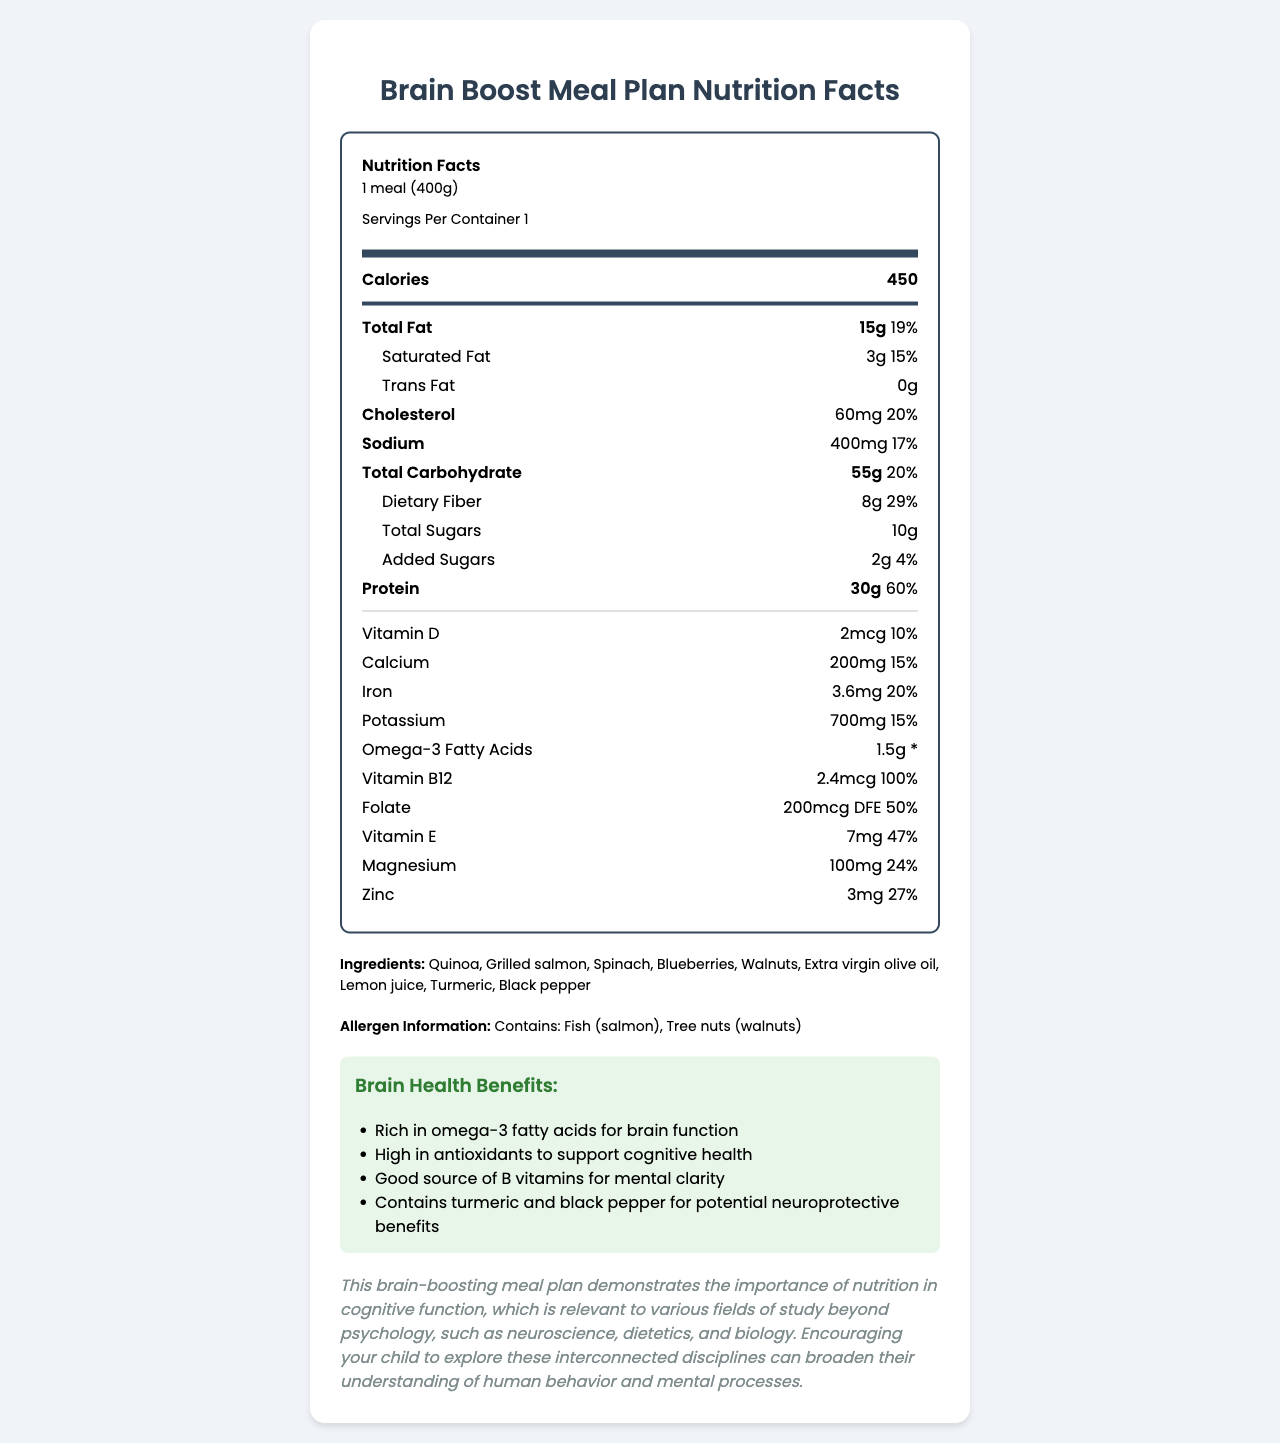what is the serving size of this meal? The document specifies that the serving size is "1 meal (400g)" in the nutrition header section.
Answer: 1 meal (400g) how many calories are in one serving? The document lists "Calories" as 450 in the bold section of the nutrition label.
Answer: 450 Which nutrient has the highest % Daily Value per serving? A. Protein B. Folate C. Dietary Fiber The document shows Protein as 60%, Folate as 50%, and Dietary Fiber as 29%. Protein has the highest % Daily Value at 60%.
Answer: A Is there any trans fat in this meal? The document states "Trans Fat" is 0g, meaning there is no trans fat in this meal.
Answer: No what are the main sources of omega-3 fatty acids in this meal? The ingredients list includes "Grilled salmon" and "Walnuts," both known for being rich in omega-3 fatty acids.
Answer: Grilled salmon, Walnuts how much protein is in one serving? The document lists Protein content as 30g.
Answer: 30g what is the amount of added sugars in this meal? The document specifies the amount of "Added Sugars" as 2g.
Answer: 2g Which vitamin has the highest % Daily Value and what is its value? The document indicates that Vitamin B12 has a % Daily Value of 100%, the highest among all the listed vitamins.
Answer: Vitamin B12, 100% Does this meal contain any allergens? The document states under allergen information that it contains Fish (salmon) and Tree nuts (walnuts).
Answer: Yes Summarize the main features of this document. The document is a well-rounded summary giving insights on nutritional aspects, health benefits, ingredients, and broader educational implications of the meal.
Answer: The document provides a detailed Nutrition Facts label for a balanced meal designed to support brain health and cognitive function. It lists the serving size, caloric content, nutrient amounts, and % Daily Values for various nutrients. Ingredients, allergen information, and brain health benefits are also included. Additionally, a parental guidance note highlights the relevance of nutrition to fields of study beyond psychology. What is the % Daily Value of Vitamin E in this meal? A. 10% B. 24% C. 47% D. 50% The document shows that the % Daily Value of Vitamin E is 47%.
Answer: C Does this document provide information on the sugar content? The document details "Total Sugars" as 10g and "Added Sugars" as 2g.
Answer: Yes What are the listed brain health benefits of this meal plan? The document lists multiple brain health benefits under Brain Health Benefits, including omega-3 fatty acids, antioxidants, B vitamins, and neuroprotective benefits of turmeric and black pepper.
Answer: Rich in omega-3 fatty acids for brain function, High in antioxidants to support cognitive health, Good source of B vitamins for mental clarity, Contains turmeric and black pepper for potential neuroprotective benefits What are the specific fields of study mentioned in the parental guidance note? The document's parental guidance note mentions neuroscience, dietetics, and biology as fields interconnected with the relevance of nutrition in cognitive function.
Answer: Neuroscience, Dietetics, Biology what is the exact amount of dietary fiber per serving? The document specifies that the Dietary Fiber content is 8g.
Answer: 8g How many % Daily Value of Iron does one serving provide? The document lists Iron as providing 20% of the % Daily Value.
Answer: 20% Why might turmeric and black pepper be included in this meal plan? The document claims that turmeric and black pepper offer potential neuroprotective benefits, contributing to brain health.
Answer: For potential neuroprotective benefits how much cholesterol is in one serving? The document lists the Cholesterol content as 60mg.
Answer: 60mg Which nutrient's amount could not be fully interpreted from the % Daily Value? The document lists omega-3 fatty acids as having a certain amount (1.5g) but does not provide a % Daily Value mark.
Answer: Omega-3 Fatty Acids What is the relevance of this meal plan to fields beyond psychology? The document states in the parental guidance note that understanding nutrition's role in cognitive function can broaden one's understanding of interconnected disciplines beyond psychology.
Answer: This meal plan demonstrates the importance of nutrition in cognitive function, relevant to fields such as neuroscience, dietetics, and biology. why are blueberries included in the ingredients list? The document lists "High in antioxidants to support cognitive health" as one of the brain health benefits, and blueberries are known for their high antioxidant content.
Answer: Rich in antioxidants to support cognitive health 